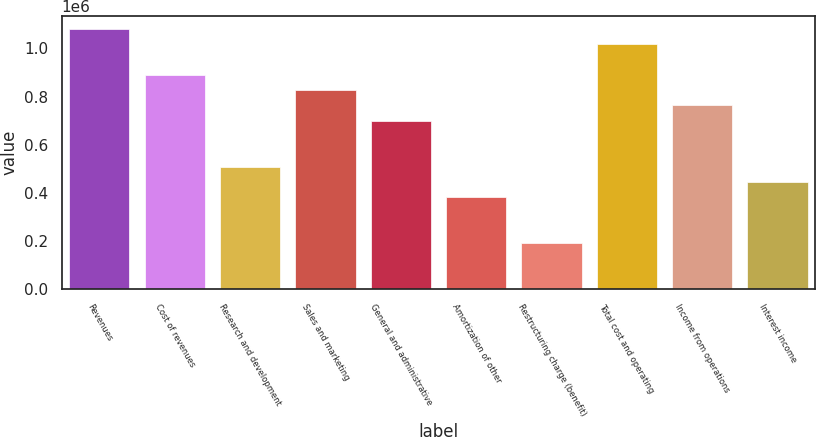<chart> <loc_0><loc_0><loc_500><loc_500><bar_chart><fcel>Revenues<fcel>Cost of revenues<fcel>Research and development<fcel>Sales and marketing<fcel>General and administrative<fcel>Amortization of other<fcel>Restructuring charge (benefit)<fcel>Total cost and operating<fcel>Income from operations<fcel>Interest income<nl><fcel>1.08189e+06<fcel>890968<fcel>509125<fcel>827328<fcel>700046<fcel>381844<fcel>190922<fcel>1.01825e+06<fcel>763687<fcel>445484<nl></chart> 